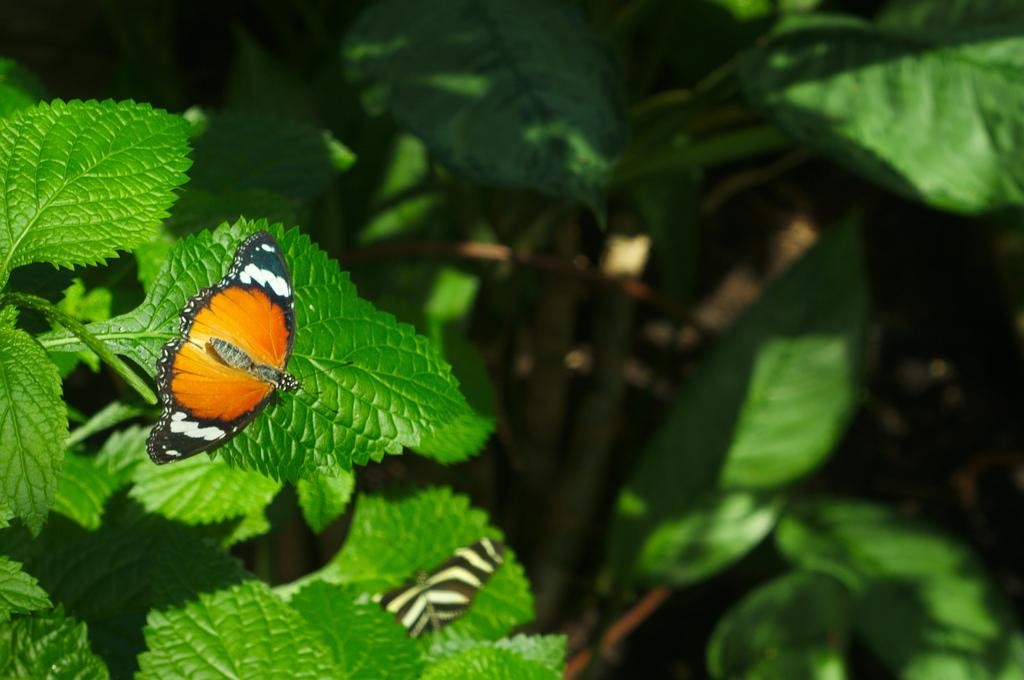What type of animals can be seen in the image? There are butterflies in the image. Where are the butterflies located? The butterflies are on leaves in the image. Can you describe the leaves in the image? The leaves have stems in the image. What type of health advice can be seen in the image? There is no health advice present in the image; it features butterflies on leaves. What type of jeans are the butterflies wearing in the image? Butterflies do not wear jeans, as they are insects and not human beings. 